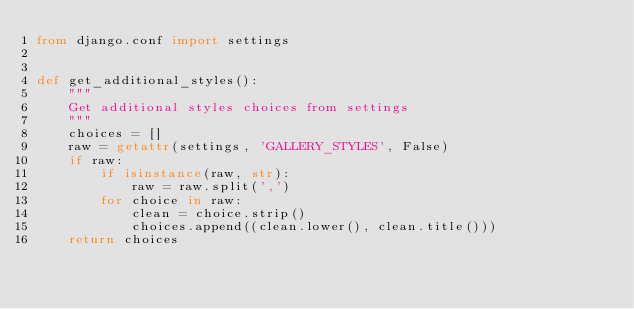Convert code to text. <code><loc_0><loc_0><loc_500><loc_500><_Python_>from django.conf import settings


def get_additional_styles():
    """
    Get additional styles choices from settings
    """
    choices = []
    raw = getattr(settings, 'GALLERY_STYLES', False)
    if raw:
        if isinstance(raw, str):
            raw = raw.split(',')
        for choice in raw:
            clean = choice.strip()
            choices.append((clean.lower(), clean.title()))
    return choices
</code> 